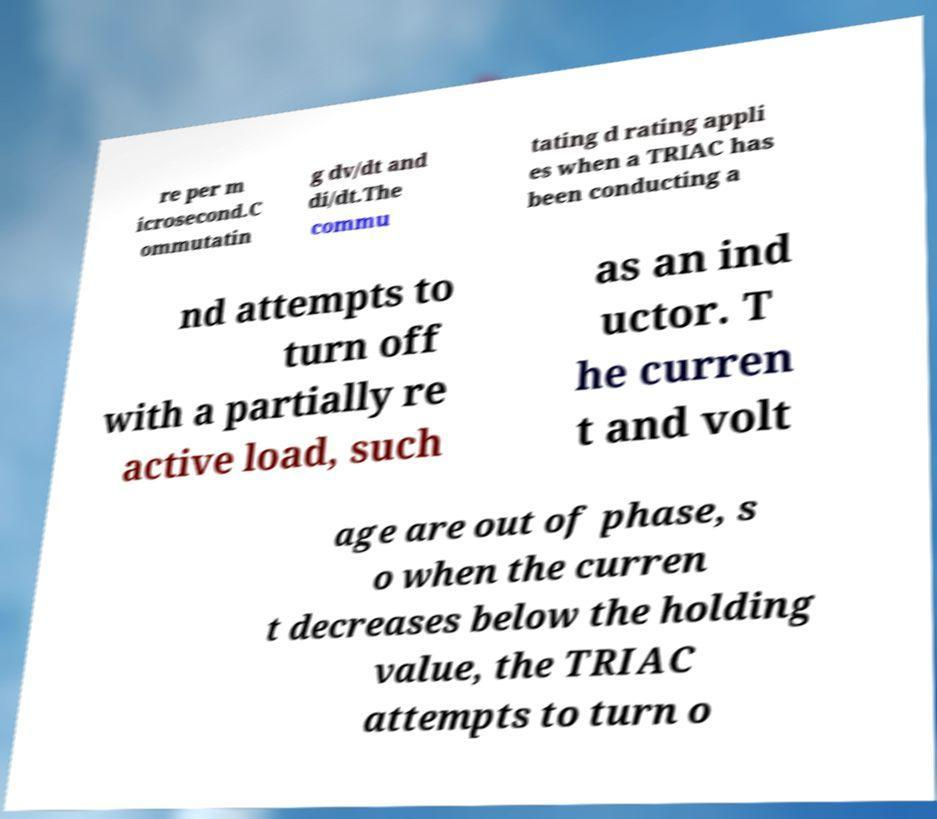Can you accurately transcribe the text from the provided image for me? re per m icrosecond.C ommutatin g dv/dt and di/dt.The commu tating d rating appli es when a TRIAC has been conducting a nd attempts to turn off with a partially re active load, such as an ind uctor. T he curren t and volt age are out of phase, s o when the curren t decreases below the holding value, the TRIAC attempts to turn o 